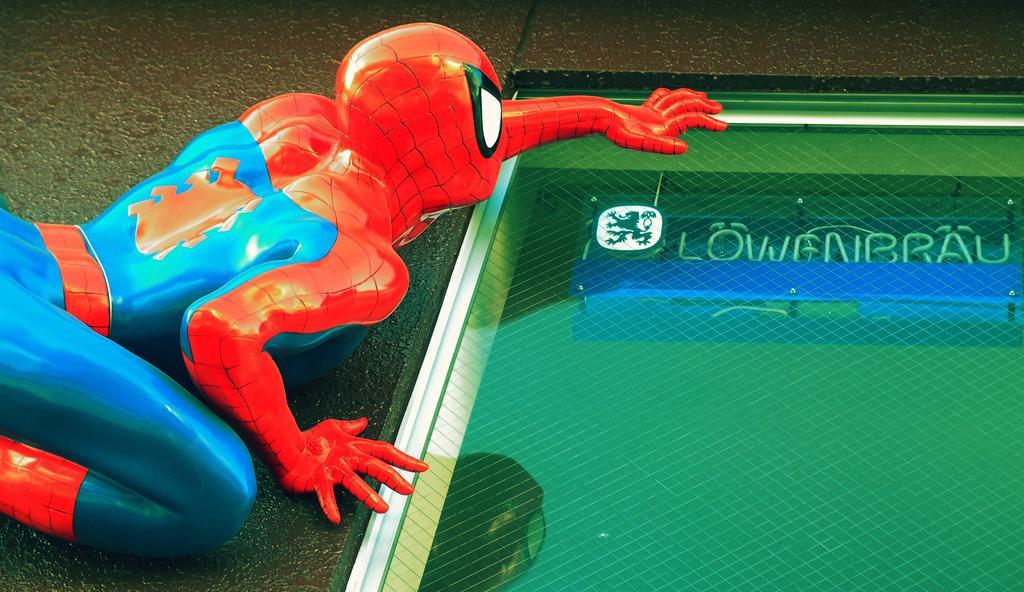How would you summarize this image in a sentence or two? In this picture we can see the spider man toy. On the right side of the toy it looks like a window. Behind the window there is a name board, logo and screws. 